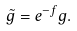<formula> <loc_0><loc_0><loc_500><loc_500>\tilde { g } = e ^ { - f } g .</formula> 